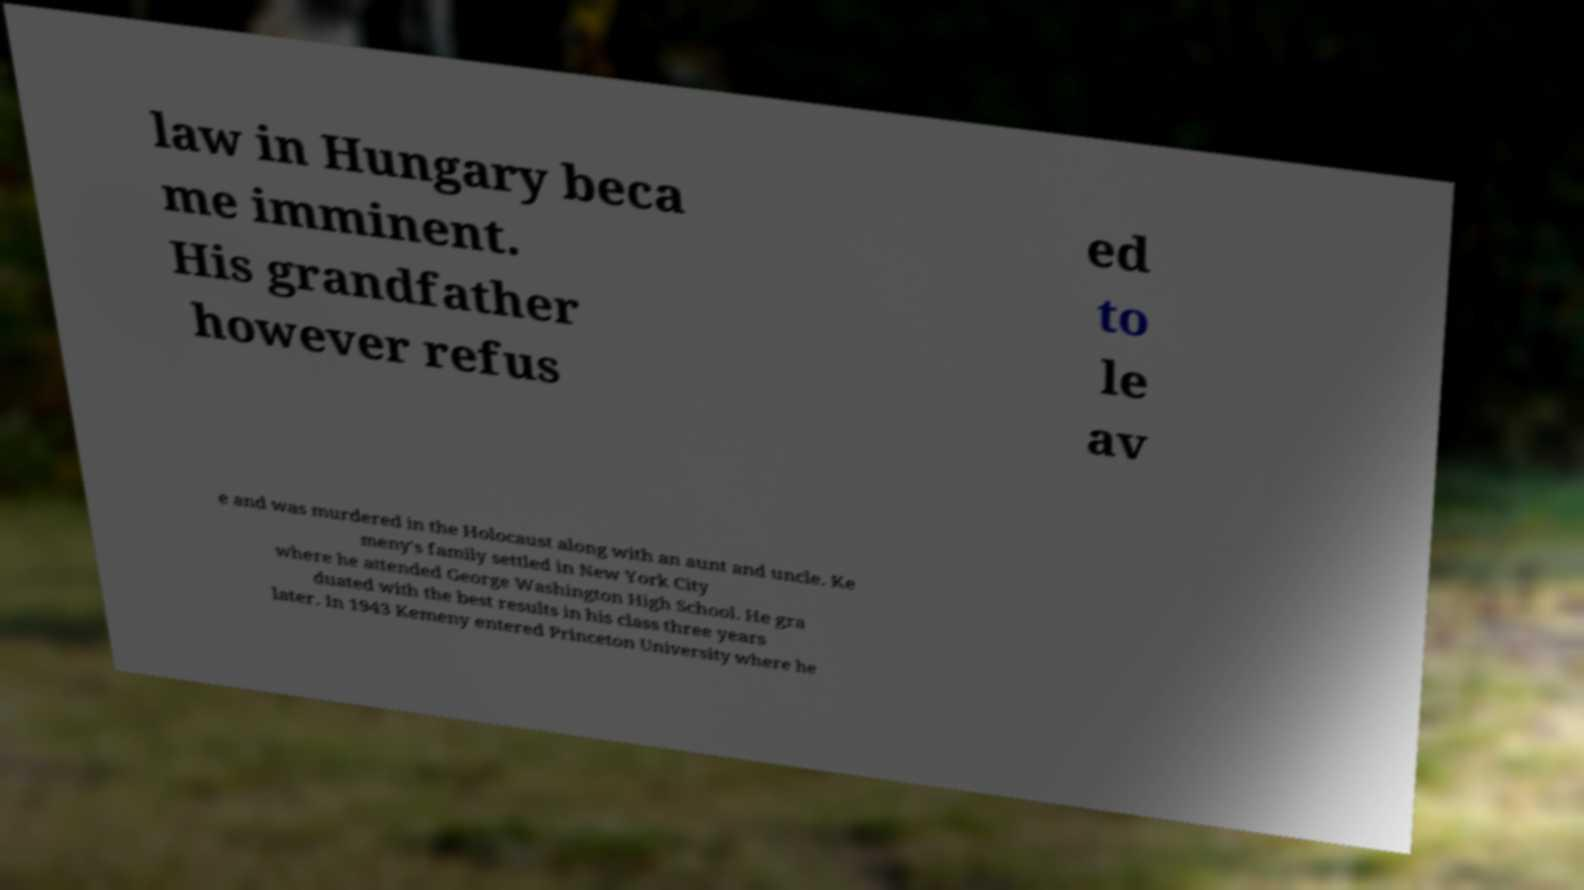Please read and relay the text visible in this image. What does it say? law in Hungary beca me imminent. His grandfather however refus ed to le av e and was murdered in the Holocaust along with an aunt and uncle. Ke meny's family settled in New York City where he attended George Washington High School. He gra duated with the best results in his class three years later. In 1943 Kemeny entered Princeton University where he 